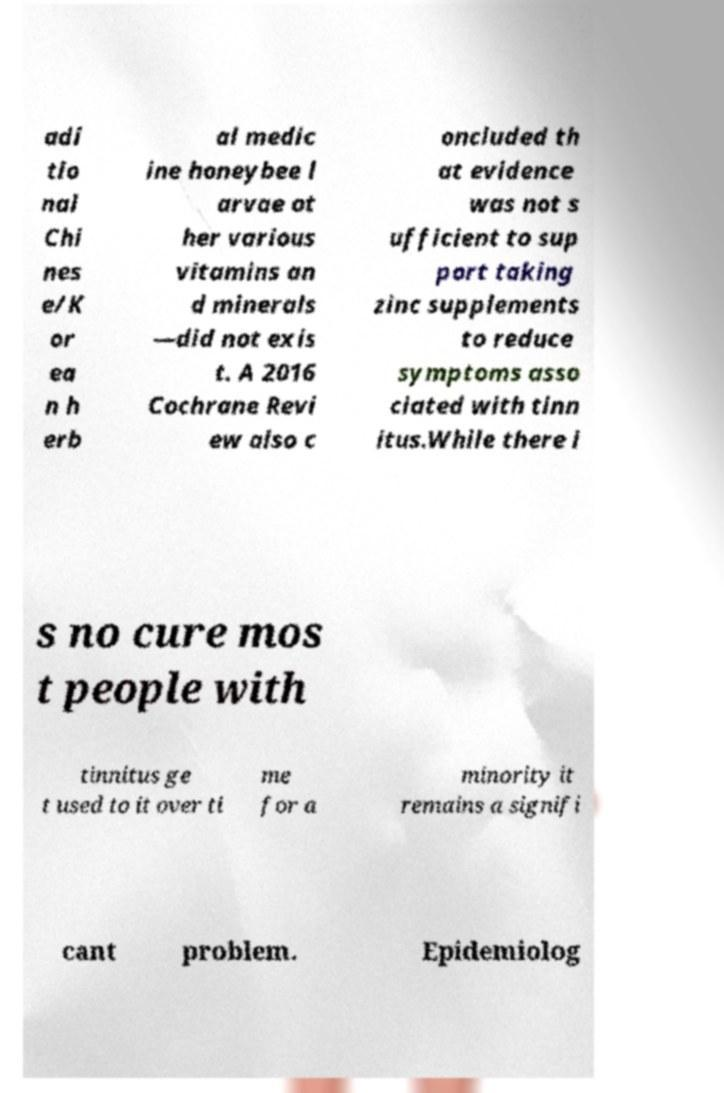I need the written content from this picture converted into text. Can you do that? adi tio nal Chi nes e/K or ea n h erb al medic ine honeybee l arvae ot her various vitamins an d minerals —did not exis t. A 2016 Cochrane Revi ew also c oncluded th at evidence was not s ufficient to sup port taking zinc supplements to reduce symptoms asso ciated with tinn itus.While there i s no cure mos t people with tinnitus ge t used to it over ti me for a minority it remains a signifi cant problem. Epidemiolog 